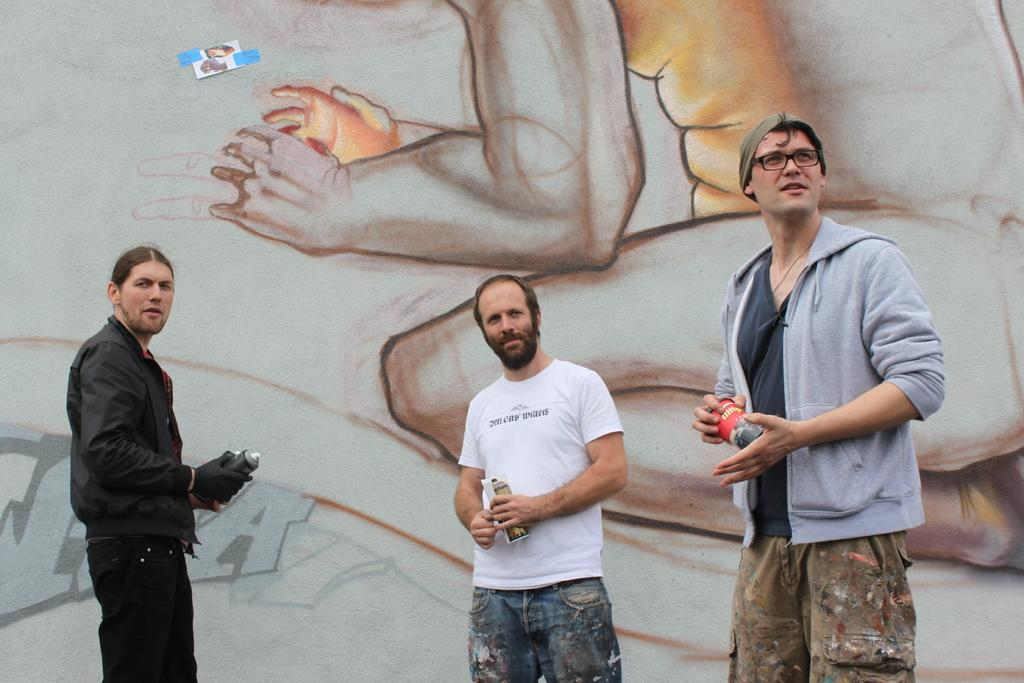What are the people in the image doing? The people in the image are standing and holding paint spray bottles. What might the people be using the paint spray bottles for? The people might be using the paint spray bottles to create graffiti, as there is graffiti on the wall in the background of the image. What type of creature can be seen running away from the bomb in the image? There is no bomb or creature present in the image. 